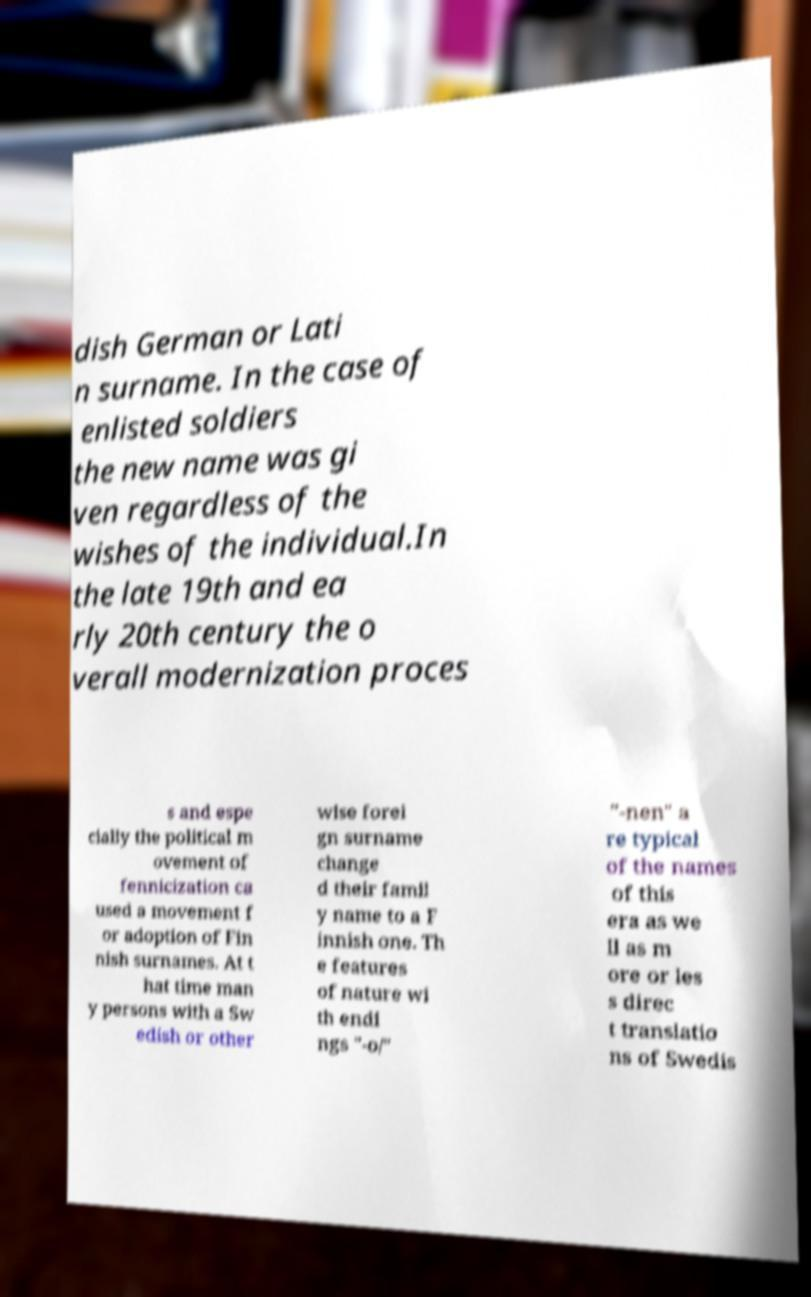Could you extract and type out the text from this image? dish German or Lati n surname. In the case of enlisted soldiers the new name was gi ven regardless of the wishes of the individual.In the late 19th and ea rly 20th century the o verall modernization proces s and espe cially the political m ovement of fennicization ca used a movement f or adoption of Fin nish surnames. At t hat time man y persons with a Sw edish or other wise forei gn surname change d their famil y name to a F innish one. Th e features of nature wi th endi ngs "-o/" "-nen" a re typical of the names of this era as we ll as m ore or les s direc t translatio ns of Swedis 